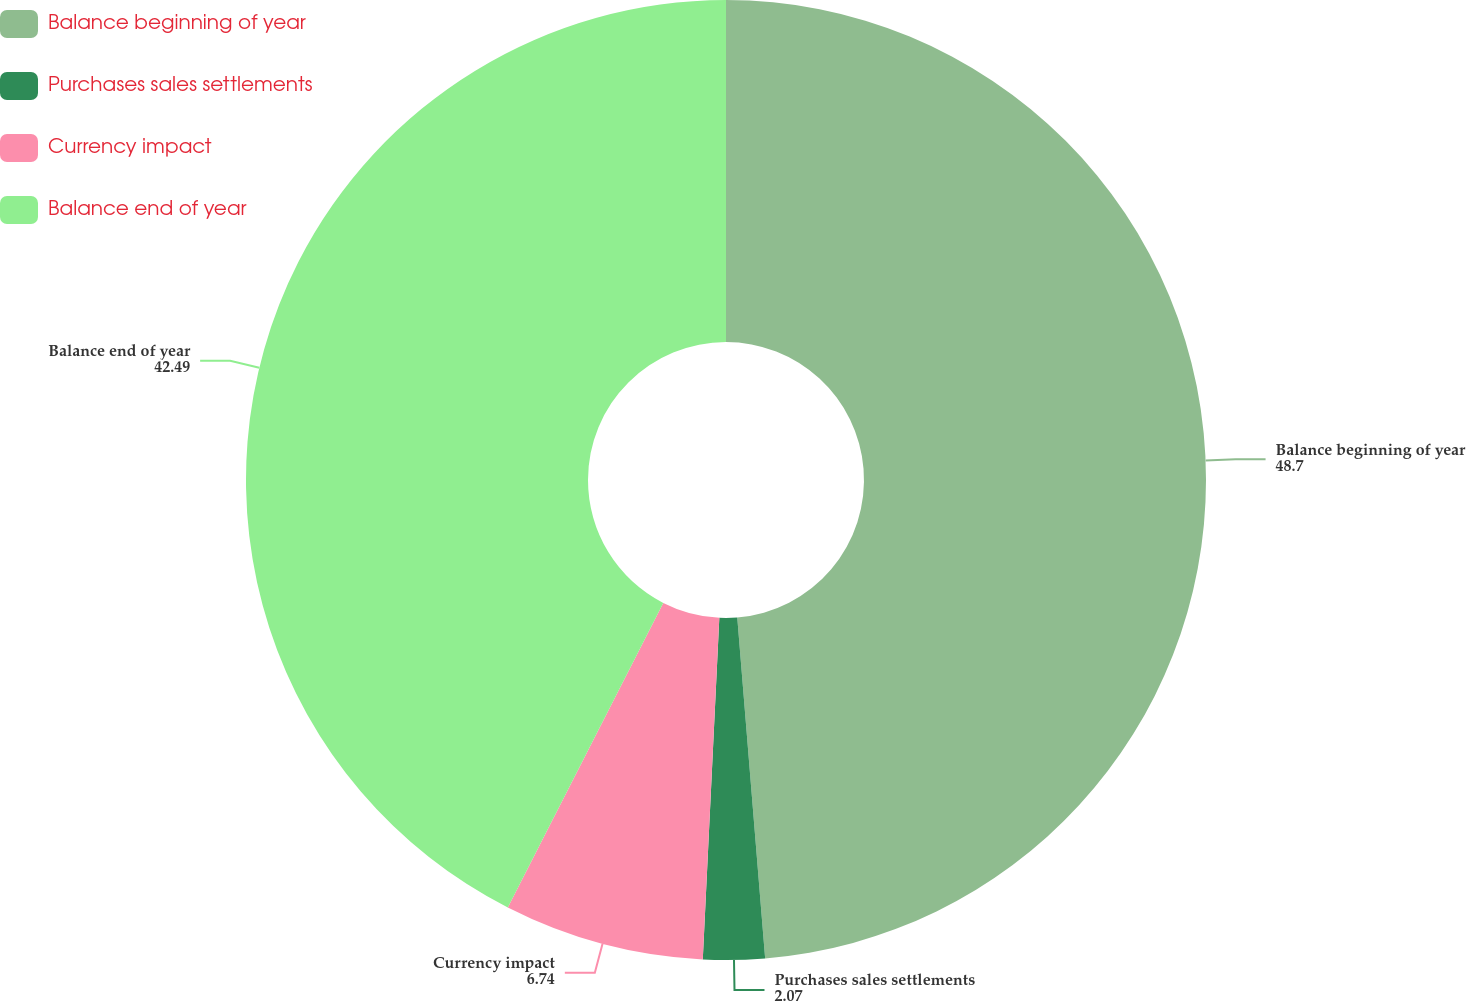Convert chart. <chart><loc_0><loc_0><loc_500><loc_500><pie_chart><fcel>Balance beginning of year<fcel>Purchases sales settlements<fcel>Currency impact<fcel>Balance end of year<nl><fcel>48.7%<fcel>2.07%<fcel>6.74%<fcel>42.49%<nl></chart> 